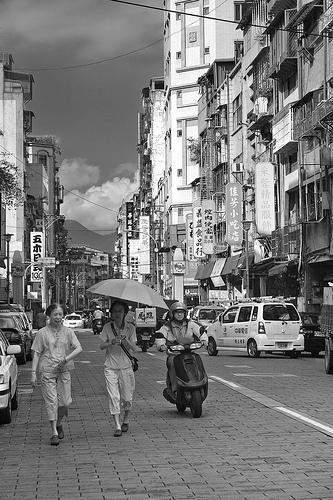How many people are there?
Give a very brief answer. 3. 